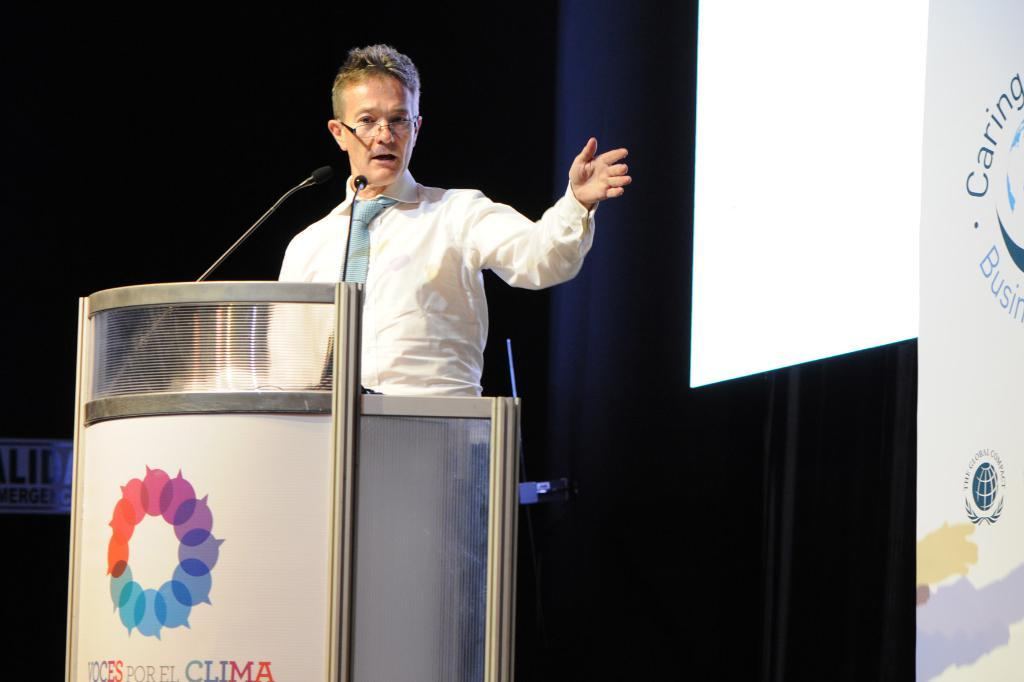<image>
Give a short and clear explanation of the subsequent image. A man speaks at the Voices por el Clima convention. 